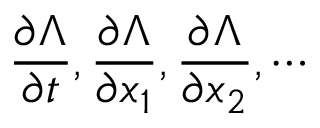<formula> <loc_0><loc_0><loc_500><loc_500>\frac { \partial \Lambda } { \partial t } , \frac { \partial \Lambda } { \partial x _ { 1 } } , \frac { \partial \Lambda } { \partial x _ { 2 } } , \cdots</formula> 